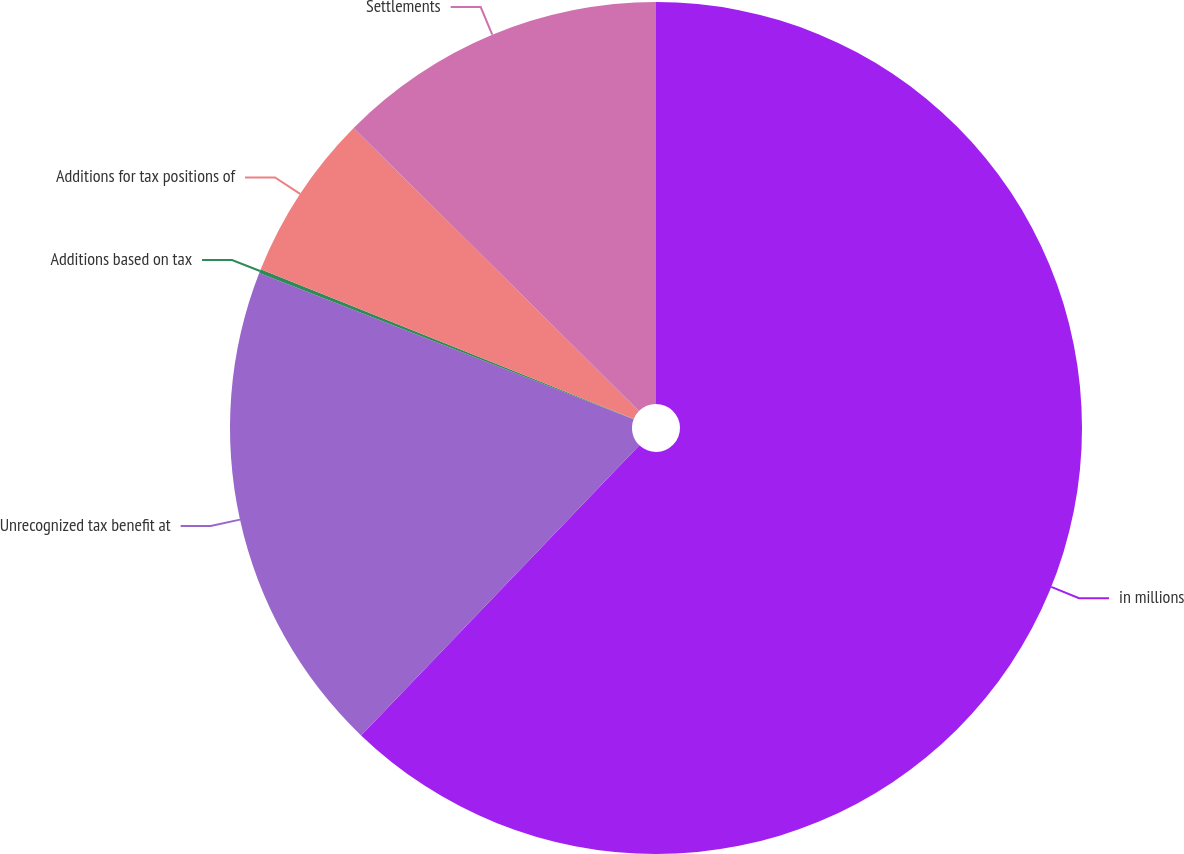<chart> <loc_0><loc_0><loc_500><loc_500><pie_chart><fcel>in millions<fcel>Unrecognized tax benefit at<fcel>Additions based on tax<fcel>Additions for tax positions of<fcel>Settlements<nl><fcel>62.17%<fcel>18.76%<fcel>0.15%<fcel>6.36%<fcel>12.56%<nl></chart> 